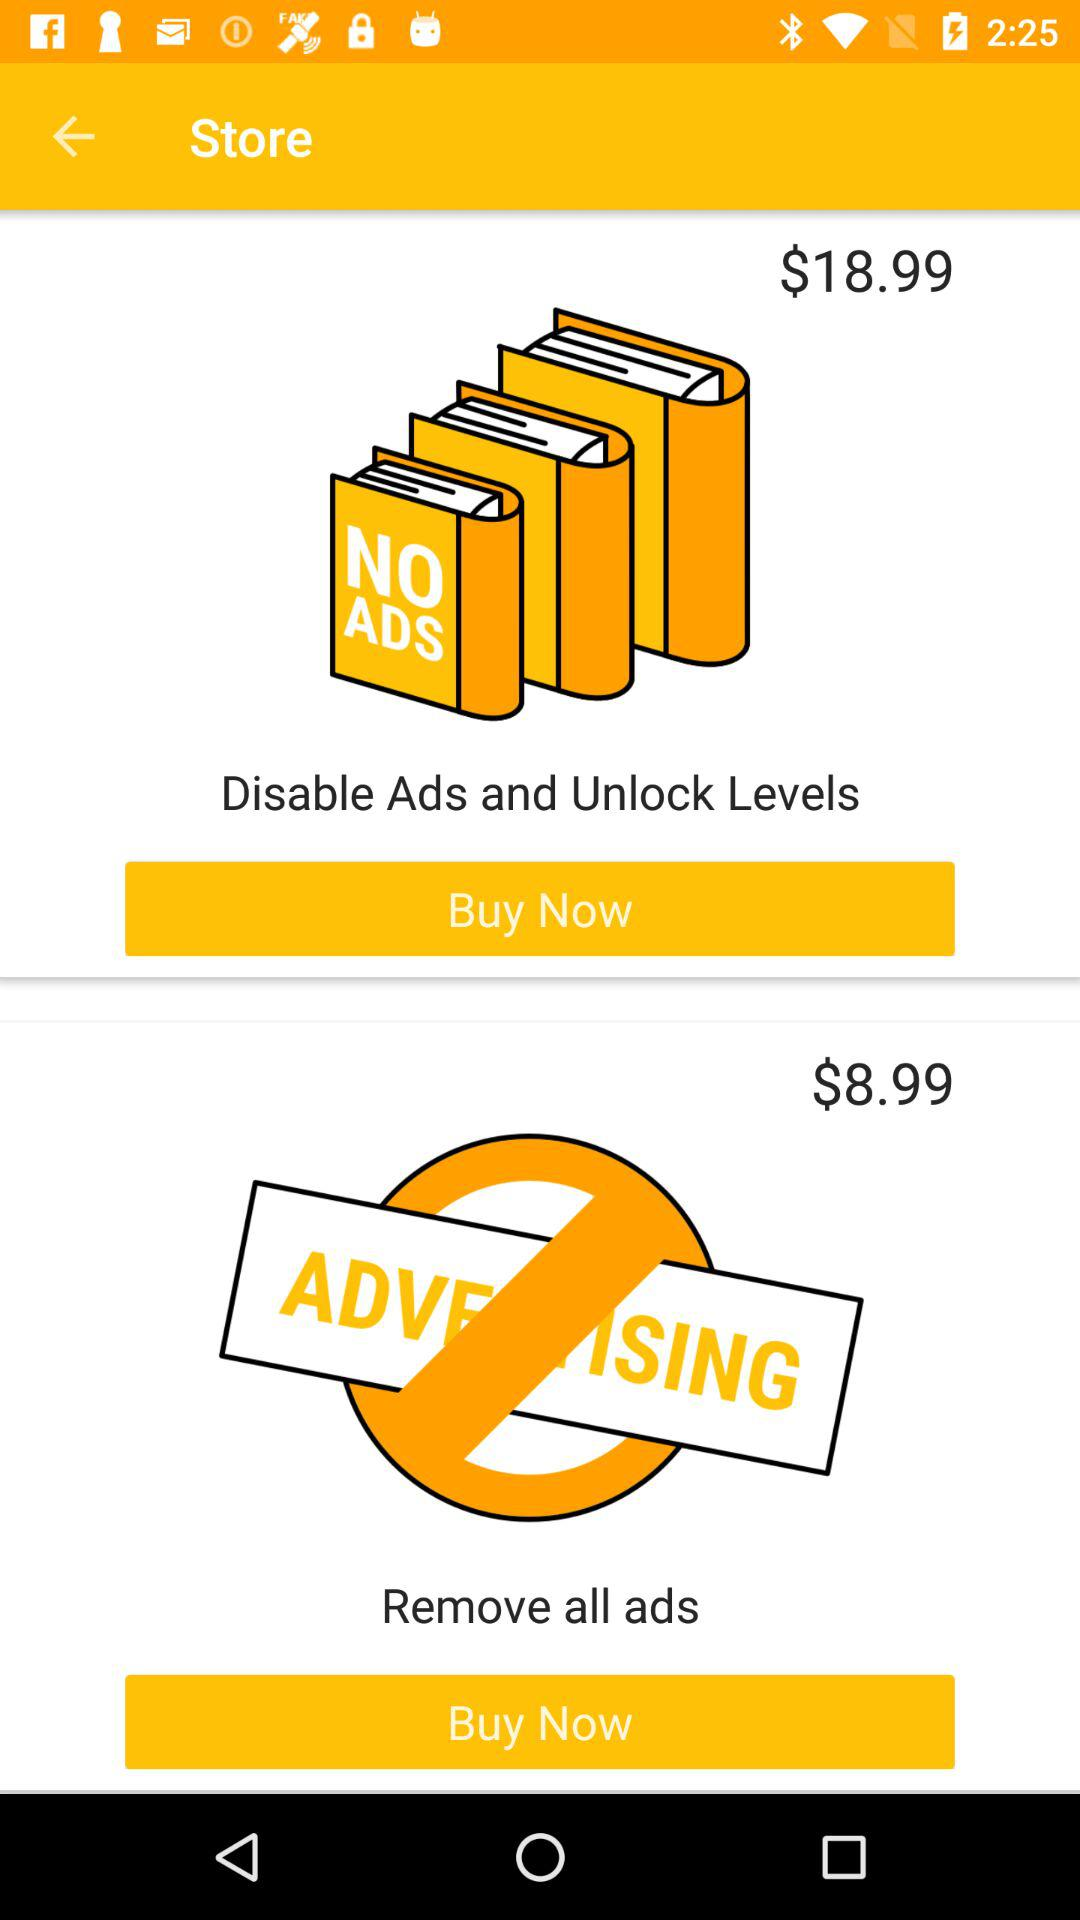What is the price for removing all the advertising? The price is $8.99. 